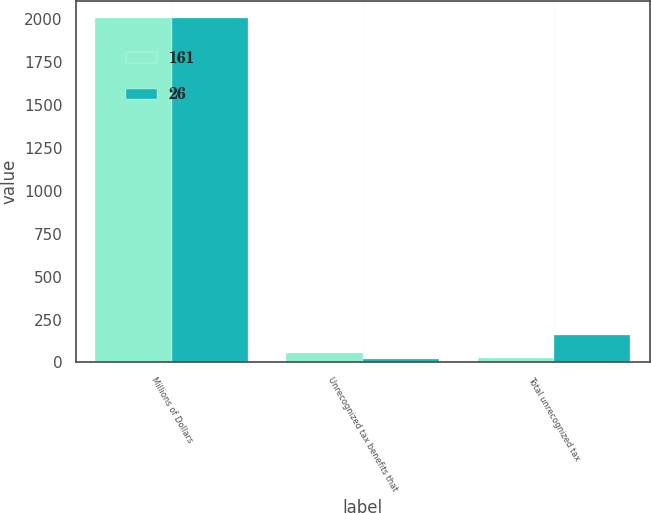<chart> <loc_0><loc_0><loc_500><loc_500><stacked_bar_chart><ecel><fcel>Millions of Dollars<fcel>Unrecognized tax benefits that<fcel>Total unrecognized tax<nl><fcel>161<fcel>2008<fcel>53<fcel>26<nl><fcel>26<fcel>2007<fcel>19<fcel>161<nl></chart> 